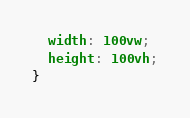<code> <loc_0><loc_0><loc_500><loc_500><_CSS_>  width: 100vw;
  height: 100vh;
}
</code> 